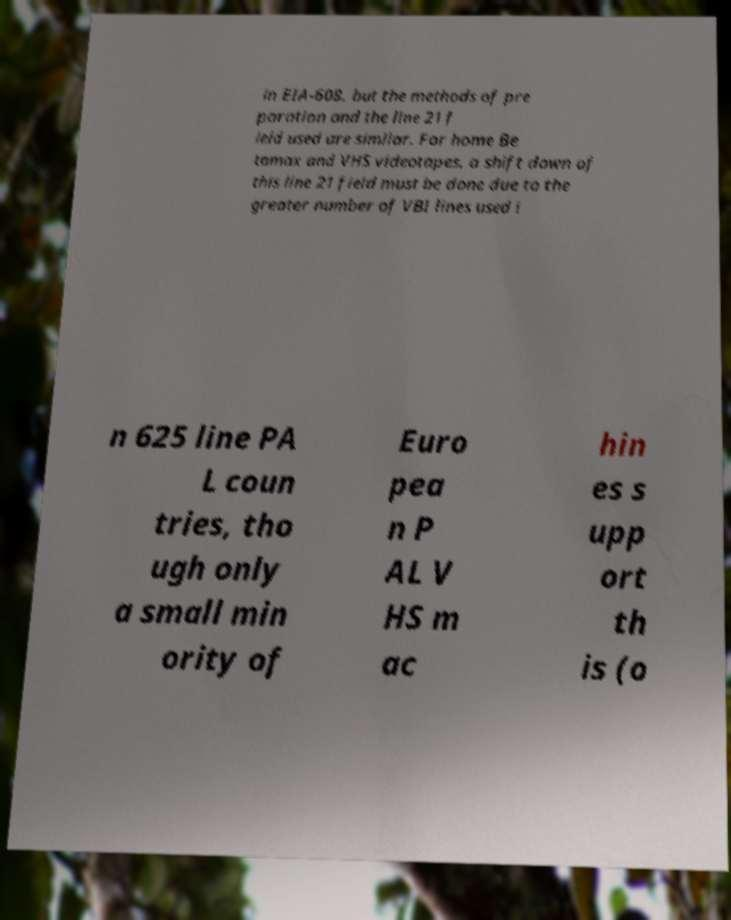What messages or text are displayed in this image? I need them in a readable, typed format. in EIA-608, but the methods of pre paration and the line 21 f ield used are similar. For home Be tamax and VHS videotapes, a shift down of this line 21 field must be done due to the greater number of VBI lines used i n 625 line PA L coun tries, tho ugh only a small min ority of Euro pea n P AL V HS m ac hin es s upp ort th is (o 